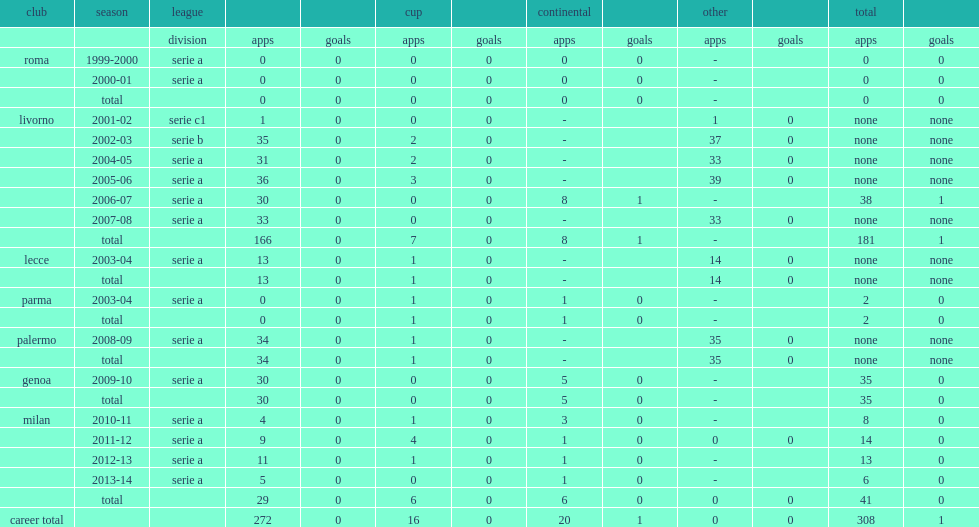How many appearances did amelia make at livorno. 181.0. 